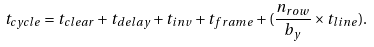<formula> <loc_0><loc_0><loc_500><loc_500>t _ { c y c l e } = t _ { c l e a r } + t _ { d e l a y } + t _ { i n v } + t _ { f r a m e } + ( \frac { n _ { r o w } } { b _ { y } } \times t _ { l i n e } ) .</formula> 